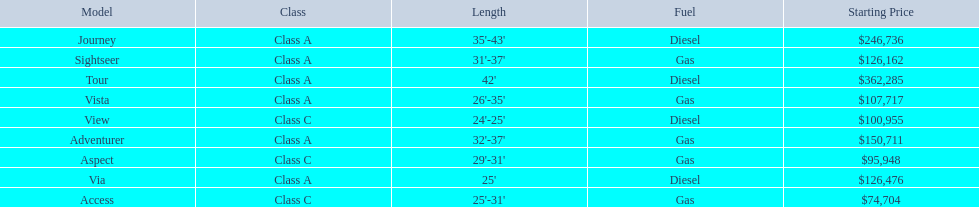Does the tour take diesel or gas? Diesel. 